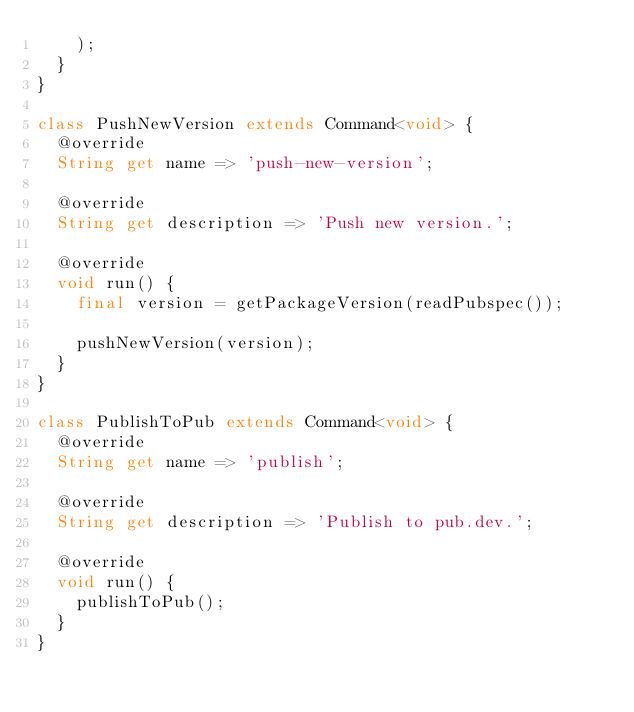Convert code to text. <code><loc_0><loc_0><loc_500><loc_500><_Dart_>    );
  }
}

class PushNewVersion extends Command<void> {
  @override
  String get name => 'push-new-version';

  @override
  String get description => 'Push new version.';

  @override
  void run() {
    final version = getPackageVersion(readPubspec());

    pushNewVersion(version);
  }
}

class PublishToPub extends Command<void> {
  @override
  String get name => 'publish';

  @override
  String get description => 'Publish to pub.dev.';

  @override
  void run() {
    publishToPub();
  }
}
</code> 